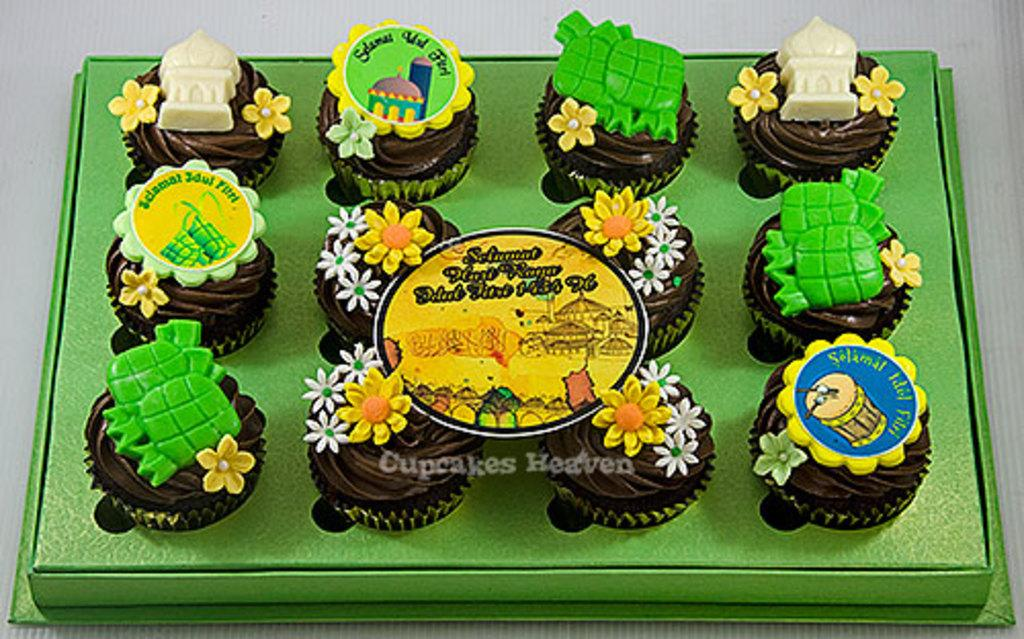What type of food can be seen in the image? There are cupcakes in the image. What is on top of the cupcakes? There are things on the cupcakes. What color is the surface on which the cupcakes are placed? The cupcakes are on a green surface. What color is the background of the image? The background of the image is white. What is the aftermath of the pin in the image? There is no pin present in the image, so there is no aftermath to discuss. 